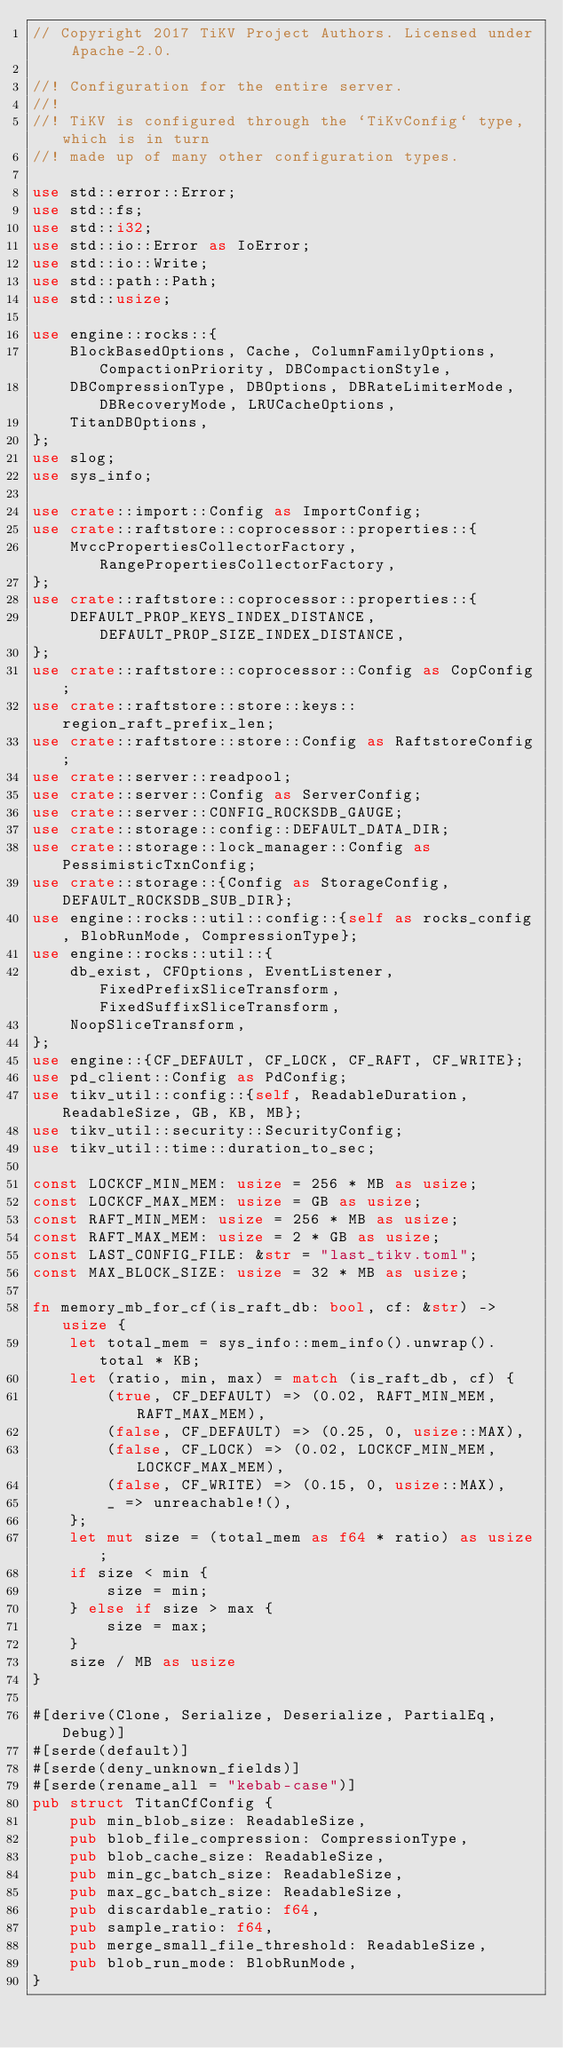<code> <loc_0><loc_0><loc_500><loc_500><_Rust_>// Copyright 2017 TiKV Project Authors. Licensed under Apache-2.0.

//! Configuration for the entire server.
//!
//! TiKV is configured through the `TiKvConfig` type, which is in turn
//! made up of many other configuration types.

use std::error::Error;
use std::fs;
use std::i32;
use std::io::Error as IoError;
use std::io::Write;
use std::path::Path;
use std::usize;

use engine::rocks::{
    BlockBasedOptions, Cache, ColumnFamilyOptions, CompactionPriority, DBCompactionStyle,
    DBCompressionType, DBOptions, DBRateLimiterMode, DBRecoveryMode, LRUCacheOptions,
    TitanDBOptions,
};
use slog;
use sys_info;

use crate::import::Config as ImportConfig;
use crate::raftstore::coprocessor::properties::{
    MvccPropertiesCollectorFactory, RangePropertiesCollectorFactory,
};
use crate::raftstore::coprocessor::properties::{
    DEFAULT_PROP_KEYS_INDEX_DISTANCE, DEFAULT_PROP_SIZE_INDEX_DISTANCE,
};
use crate::raftstore::coprocessor::Config as CopConfig;
use crate::raftstore::store::keys::region_raft_prefix_len;
use crate::raftstore::store::Config as RaftstoreConfig;
use crate::server::readpool;
use crate::server::Config as ServerConfig;
use crate::server::CONFIG_ROCKSDB_GAUGE;
use crate::storage::config::DEFAULT_DATA_DIR;
use crate::storage::lock_manager::Config as PessimisticTxnConfig;
use crate::storage::{Config as StorageConfig, DEFAULT_ROCKSDB_SUB_DIR};
use engine::rocks::util::config::{self as rocks_config, BlobRunMode, CompressionType};
use engine::rocks::util::{
    db_exist, CFOptions, EventListener, FixedPrefixSliceTransform, FixedSuffixSliceTransform,
    NoopSliceTransform,
};
use engine::{CF_DEFAULT, CF_LOCK, CF_RAFT, CF_WRITE};
use pd_client::Config as PdConfig;
use tikv_util::config::{self, ReadableDuration, ReadableSize, GB, KB, MB};
use tikv_util::security::SecurityConfig;
use tikv_util::time::duration_to_sec;

const LOCKCF_MIN_MEM: usize = 256 * MB as usize;
const LOCKCF_MAX_MEM: usize = GB as usize;
const RAFT_MIN_MEM: usize = 256 * MB as usize;
const RAFT_MAX_MEM: usize = 2 * GB as usize;
const LAST_CONFIG_FILE: &str = "last_tikv.toml";
const MAX_BLOCK_SIZE: usize = 32 * MB as usize;

fn memory_mb_for_cf(is_raft_db: bool, cf: &str) -> usize {
    let total_mem = sys_info::mem_info().unwrap().total * KB;
    let (ratio, min, max) = match (is_raft_db, cf) {
        (true, CF_DEFAULT) => (0.02, RAFT_MIN_MEM, RAFT_MAX_MEM),
        (false, CF_DEFAULT) => (0.25, 0, usize::MAX),
        (false, CF_LOCK) => (0.02, LOCKCF_MIN_MEM, LOCKCF_MAX_MEM),
        (false, CF_WRITE) => (0.15, 0, usize::MAX),
        _ => unreachable!(),
    };
    let mut size = (total_mem as f64 * ratio) as usize;
    if size < min {
        size = min;
    } else if size > max {
        size = max;
    }
    size / MB as usize
}

#[derive(Clone, Serialize, Deserialize, PartialEq, Debug)]
#[serde(default)]
#[serde(deny_unknown_fields)]
#[serde(rename_all = "kebab-case")]
pub struct TitanCfConfig {
    pub min_blob_size: ReadableSize,
    pub blob_file_compression: CompressionType,
    pub blob_cache_size: ReadableSize,
    pub min_gc_batch_size: ReadableSize,
    pub max_gc_batch_size: ReadableSize,
    pub discardable_ratio: f64,
    pub sample_ratio: f64,
    pub merge_small_file_threshold: ReadableSize,
    pub blob_run_mode: BlobRunMode,
}
</code> 